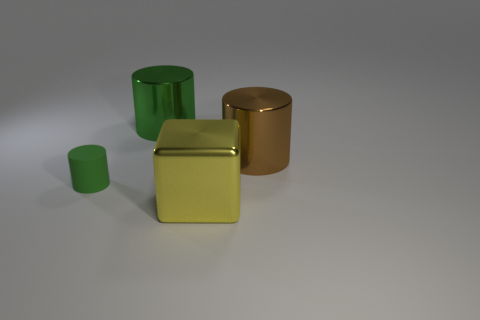There is a cylinder that is in front of the large metal cylinder that is in front of the large shiny cylinder that is on the left side of the big brown cylinder; what is it made of?
Ensure brevity in your answer.  Rubber. There is a shiny cylinder that is on the right side of the big yellow metallic block; does it have the same size as the green object in front of the brown metal object?
Make the answer very short. No. How many other things are made of the same material as the big yellow cube?
Ensure brevity in your answer.  2. What number of rubber objects are either large yellow blocks or purple balls?
Provide a succinct answer. 0. Are there fewer matte objects than small green balls?
Your answer should be very brief. No. There is a cube; does it have the same size as the green thing that is on the right side of the green rubber cylinder?
Give a very brief answer. Yes. Is there anything else that is the same shape as the large yellow thing?
Keep it short and to the point. No. What size is the green rubber cylinder?
Ensure brevity in your answer.  Small. Are there fewer brown objects on the right side of the big brown object than yellow objects?
Provide a succinct answer. Yes. Do the matte cylinder and the yellow metallic block have the same size?
Provide a short and direct response. No. 